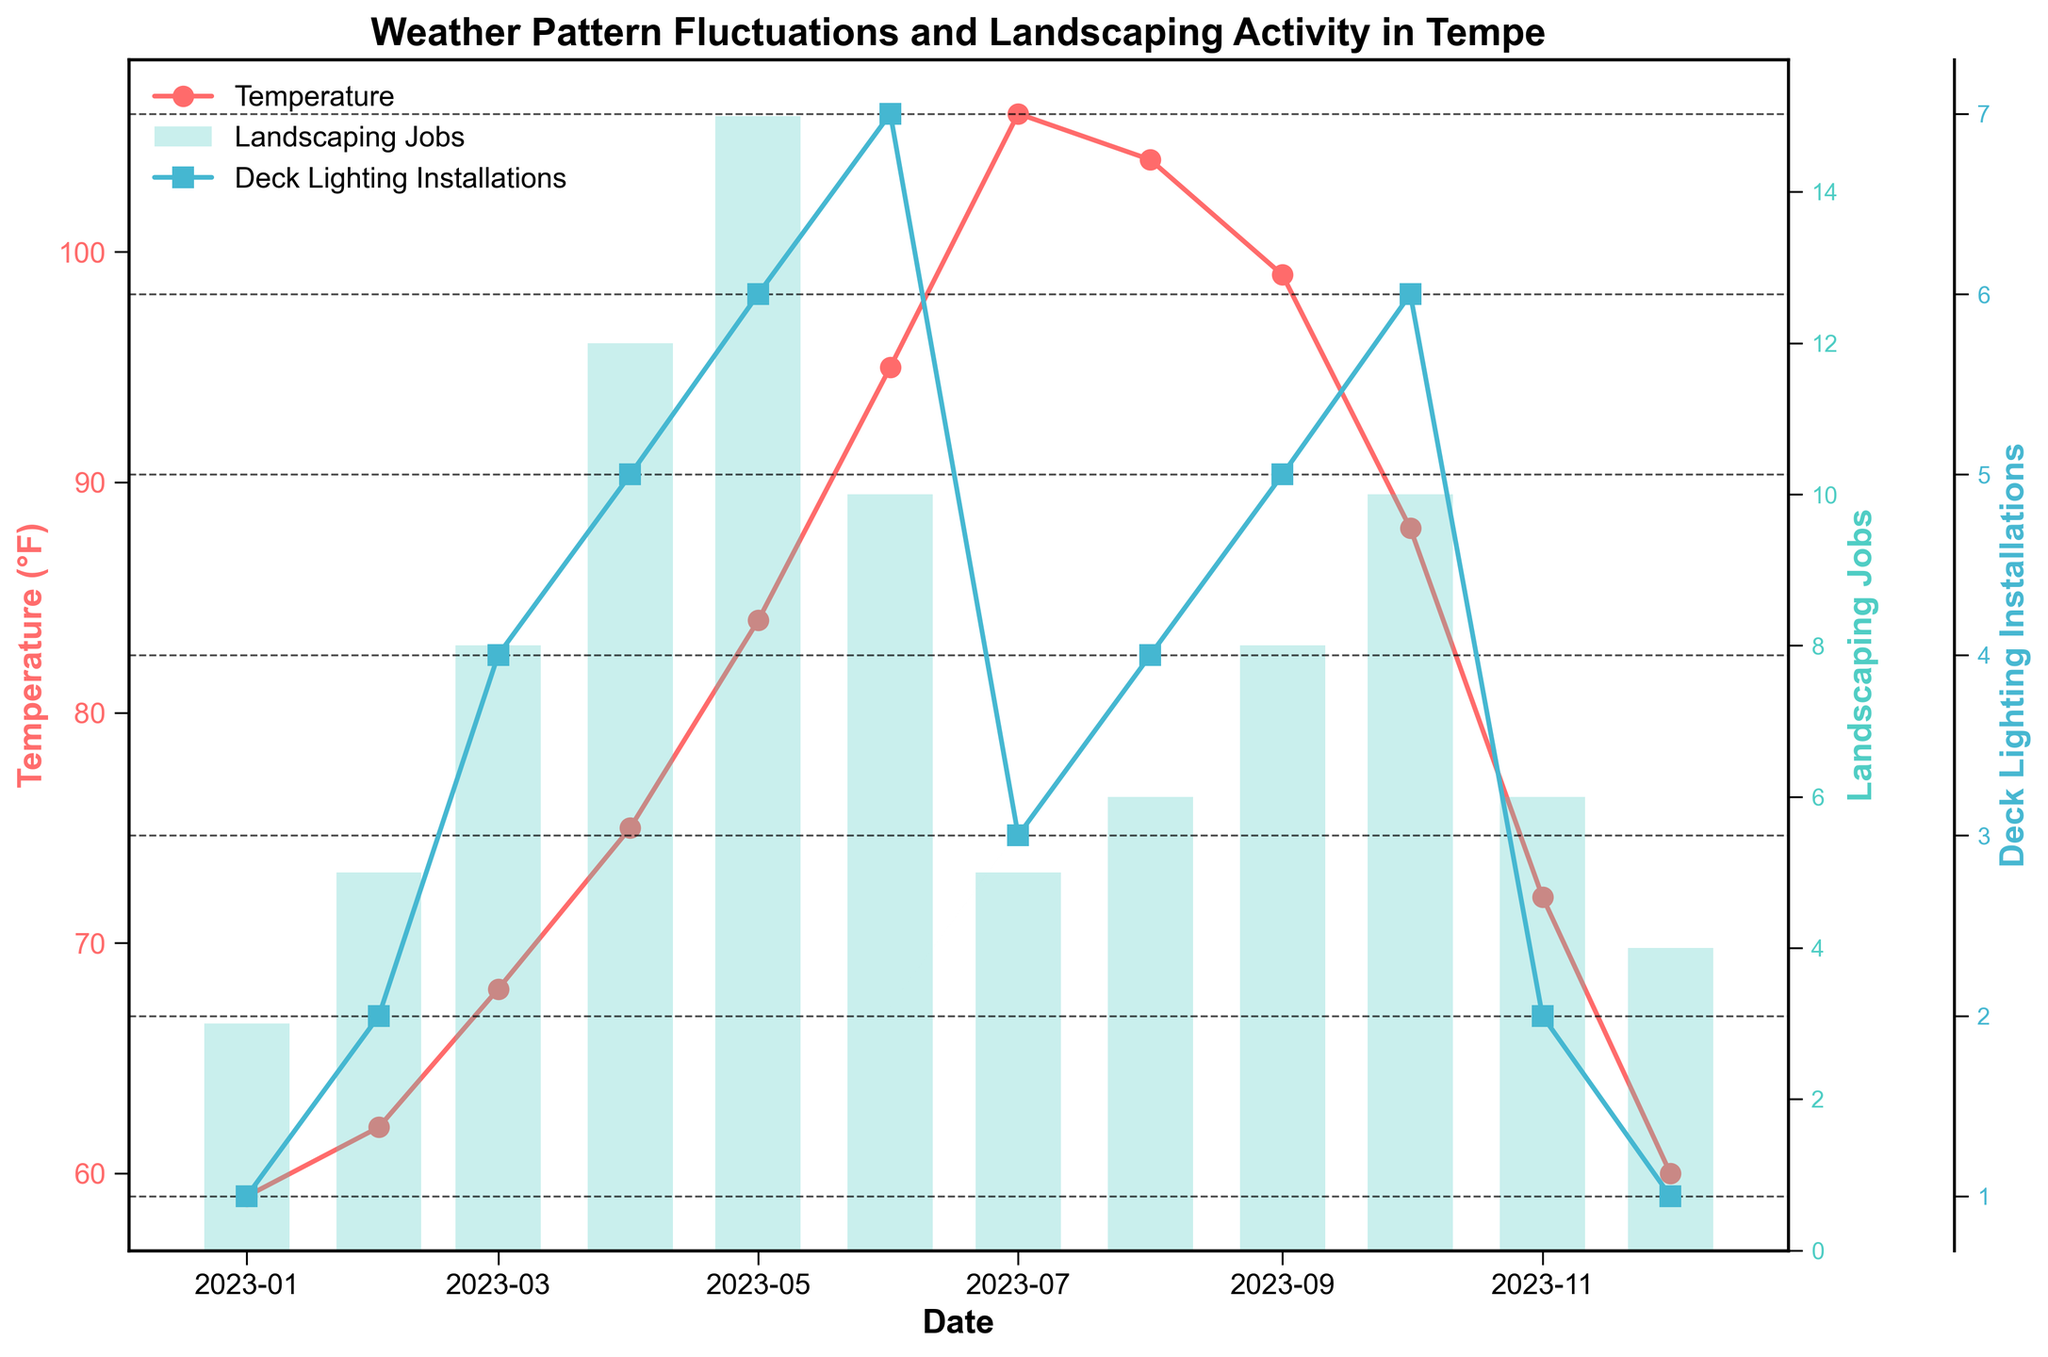What is the title of the figure? The title of the figure is centered at the top and describes the overall content of the plot. It reads "Weather Pattern Fluctuations and Landscaping Activity in Tempe."
Answer: Weather Pattern Fluctuations and Landscaping Activity in Tempe What does the x-axis represent? The x-axis runs horizontally along the bottom of the plot and represents the dates, which are monthly intervals from January to December 2023.
Answer: Dates Which color is used to plot the temperature? The temperature is plotted using a line with markers in a specific color. This color is red.
Answer: Red In which month were the most landscaping jobs completed? To determine the month with the most landscaping jobs, look at the highest point of the bars that represent landscaping jobs. The tallest bar corresponds to May.
Answer: May What were the temperature and the number of deck lighting installations in June? To find this, you need to look at the data points related to June. The temperature line for June shows a value of 95°F. The deck lighting installations line for June shows a value of 7.
Answer: 95°F and 7 During which month did both precipitation and solar exposure appear to be at their lowest? Scan for the lowest values in both precipitation and solar exposure. December has the least rainfall (0.2 inches) and a relatively low solar exposure (13 MJ/m²), thus meeting the lowest criteria for both.
Answer: December In which month did temperature peak, and how many landscaping jobs were there in that month? Identify the peak of the temperature line to determine the month. The highest temperature is in July at 106°F. The corresponding number of landscaping jobs in July is 5.
Answer: July and 5 How does the trend of deck lighting installations compare throughout the year? To analyze the trend of deck lighting installations, observe the line with square markers. The trend generally increases from January to June, dips in July, and then fluctuates until December.
Answer: Increased, then dipped, then fluctuated What is the average number of landscaping jobs completed in the second half of the year (July to December)? First, identify the relevant months and their corresponding values: July (5), August (6), September (8), October (10), November (6), December (4). Sum these values (5+6+8+10+6+4=39) and divide by the number of months (6).
Answer: 6.5 How did solar exposure in July compare to December? For both months, note the respective values of solar exposure. July's solar exposure was 28 MJ/m², while December's was 13 MJ/m². July's value is significantly higher.
Answer: Higher in July 